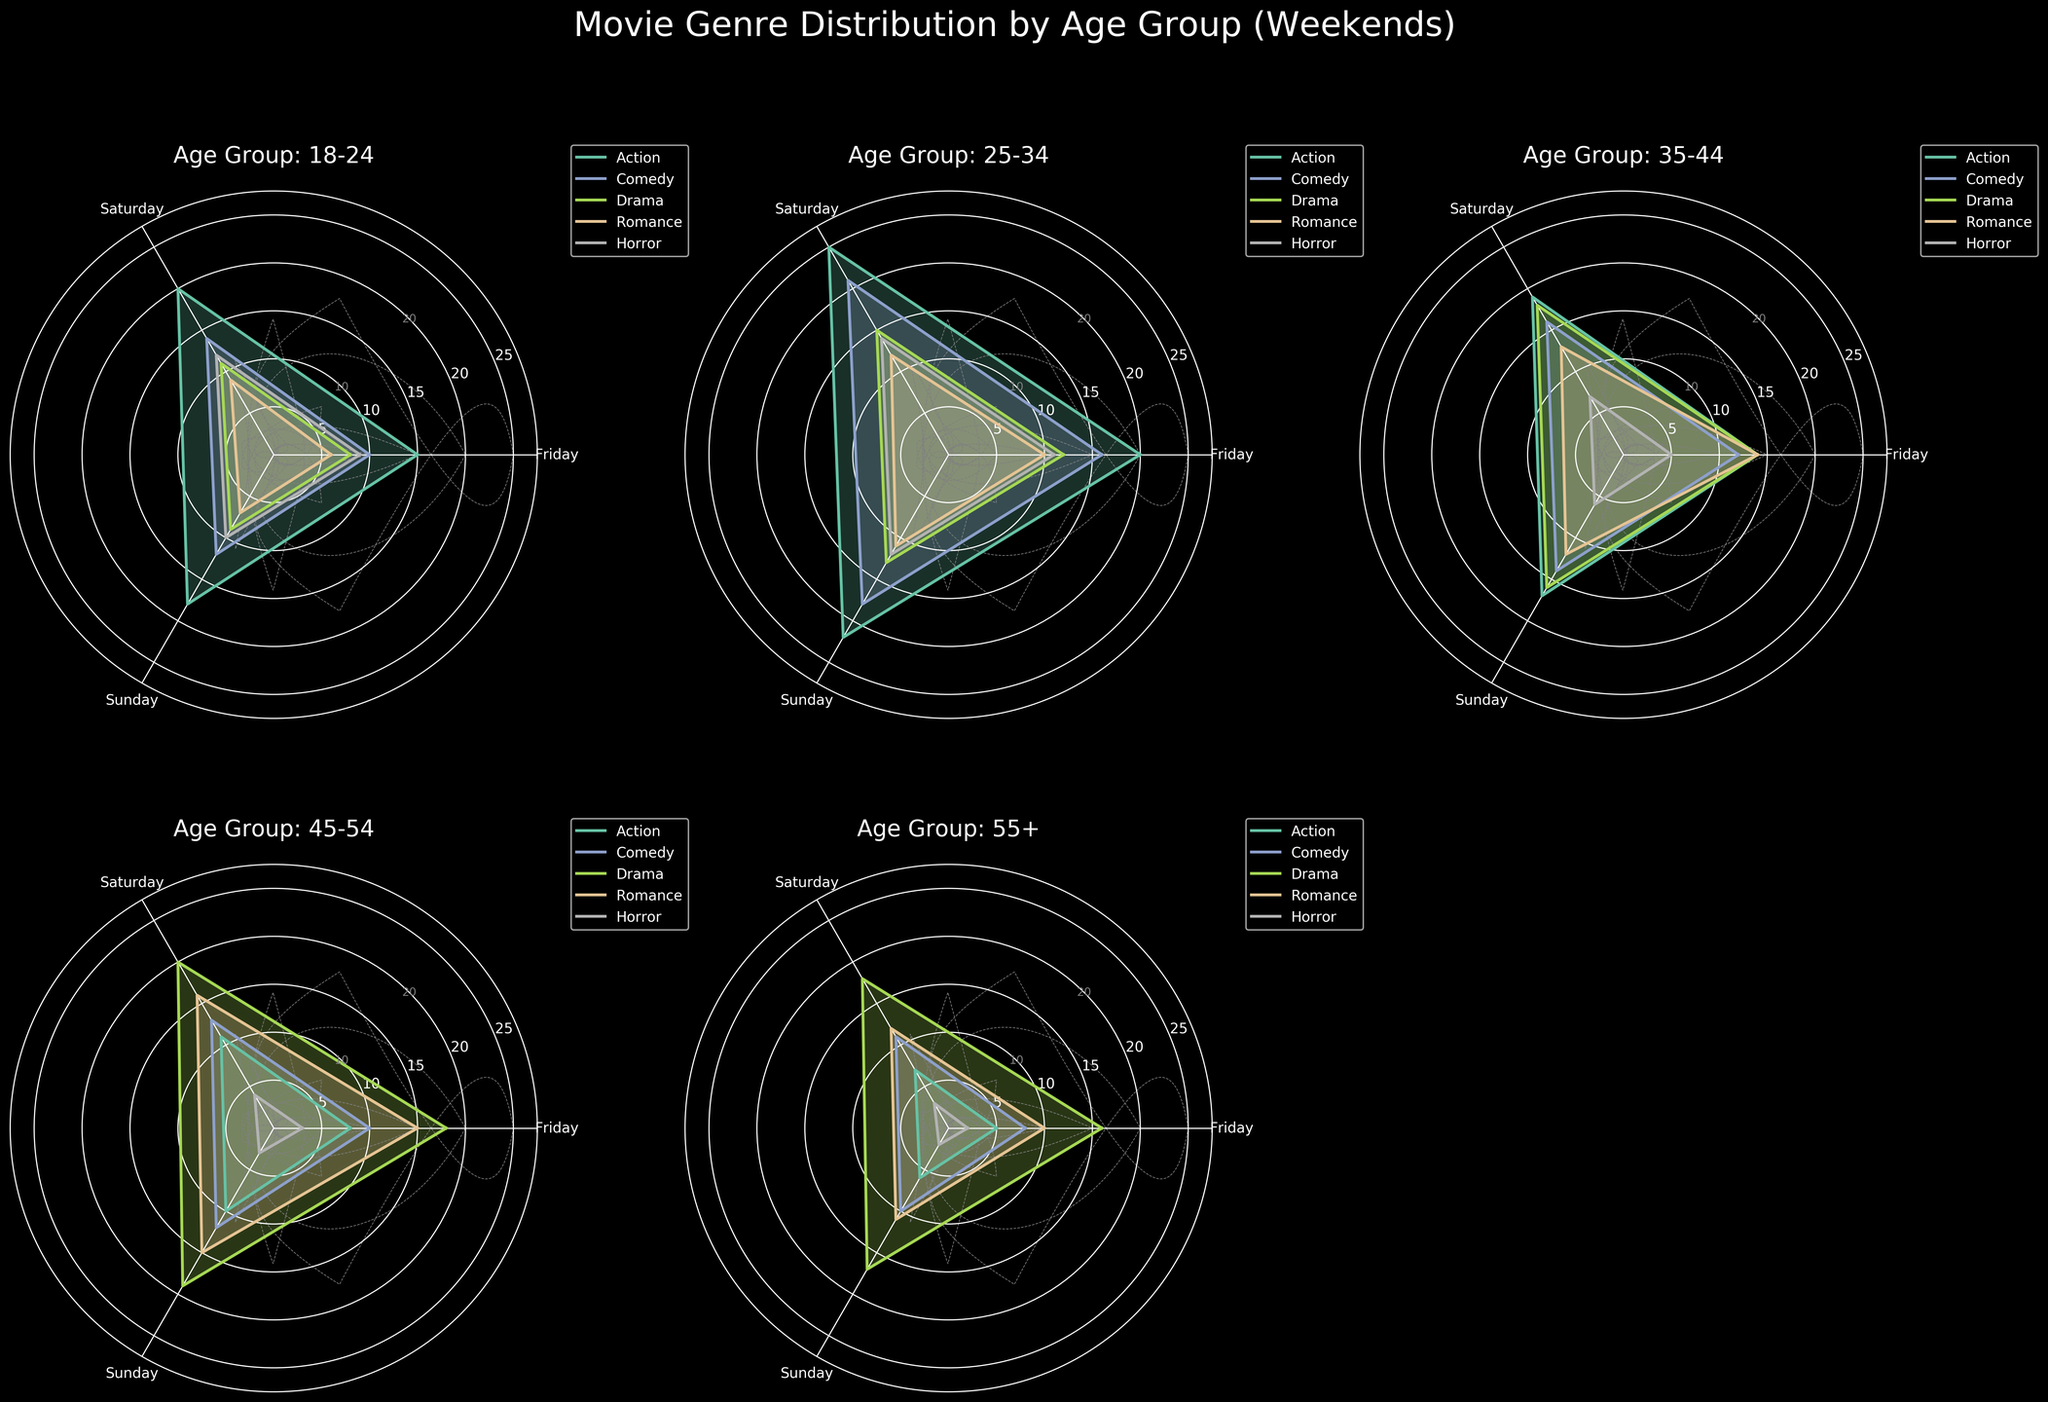What's the most watched genre by the 25-34 age group on Sundays? Look at the subplot labeled "Age Group: 25-34" and identify the genre with the highest value on Sunday. The genre "Action" has the highest peak value on the Sunday axis.
Answer: Action In which age group is Drama most consistently watched across all three days? Compare the subplots for each age group focusing on the Drama values across Friday, Saturday, and Sunday. Drama for the 45-54 age group has consistently high values with only slight variation.
Answer: 45-54 Which genre shows the largest increase in viewership from Friday to Saturday in the 18-24 age group? Focus on the subplot for age group 18-24 and calculate the difference between Saturday and Friday for each genre. Action increases by 5, Comedy by 4, Drama by 3, Romance by 3, and Horror by 3. The largest increase is for Action.
Answer: Action How does the viewership of Romance on Sunday change across different age groups? Examine the Romance values on the Sunday axis for each age group subplot. The values are 7 for 18-24, 11 for 25-34, 12 for 35-44, 15 for 45-54, and 11 for 55+. This shows a slight increase up to the 45-54 age group and a decrease for the 55+ group.
Answer: Increases up to 45-54 then decreases Which age group has the least interest in Horror based on the data? Identify the age group subplot with the lowest values for Horror across all three days. The 55+ age group consistently has the lowest values (2, 3, 2).
Answer: 55+ What can you infer about the trend of Comedy viewership on Saturdays across all age groups? Look at the Saturday values for Comedy in each age group subplot. The values (top to bottom) are: 14, 21, 16, 13, and 11. This shows a general decrease in Comedy viewership on Saturdays as age increases.
Answer: Decreases with age Which genre has the broadest distribution of viewership among the age groups on Fridays? Compare the range of viewership values for each genre on Fridays across all age group subplots. Drama shows values from 8 to 18, which is the broadest range compared to other genres.
Answer: Drama What is the total viewership of Action and Comedy on Sundays for the 35-44 age group? Add the Sunday values of Action (17) and Comedy (14) from the 35-44 age group subplot. The total is 17 + 14 = 31.
Answer: 31 